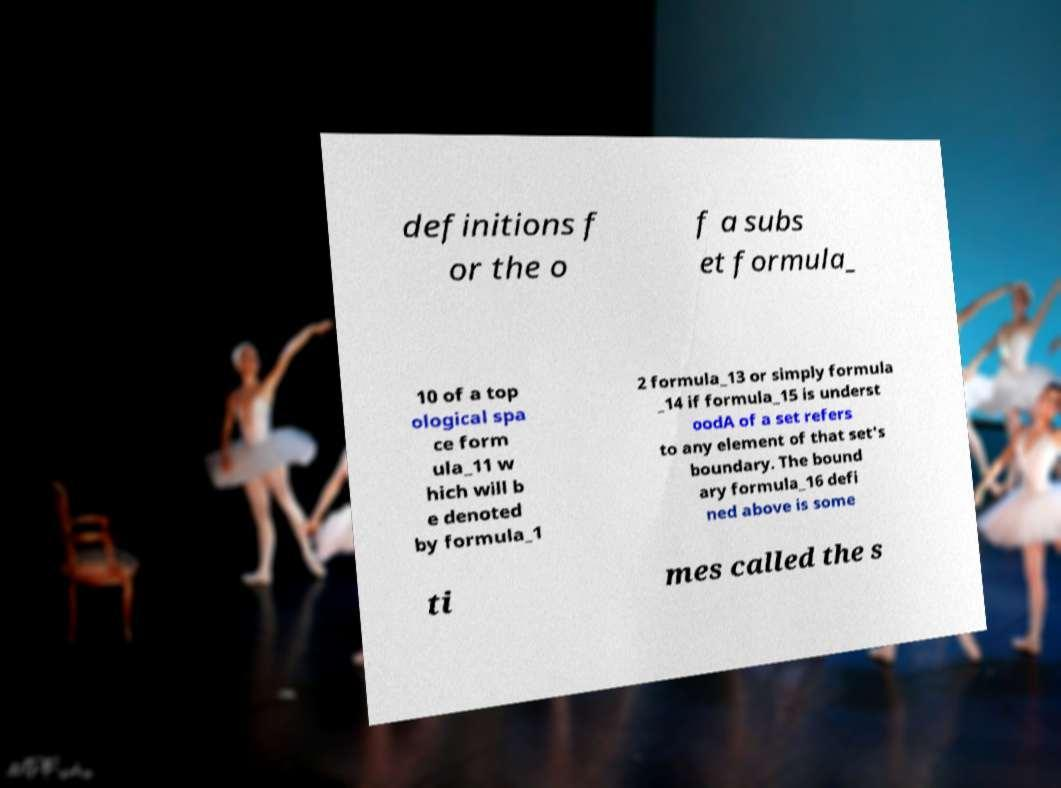Can you accurately transcribe the text from the provided image for me? definitions f or the o f a subs et formula_ 10 of a top ological spa ce form ula_11 w hich will b e denoted by formula_1 2 formula_13 or simply formula _14 if formula_15 is underst oodA of a set refers to any element of that set's boundary. The bound ary formula_16 defi ned above is some ti mes called the s 